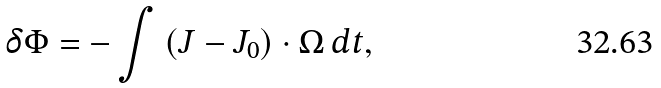<formula> <loc_0><loc_0><loc_500><loc_500>\delta \Phi = - \int { \left ( { { J } - { J } _ { 0 } } \right ) \cdot { \Omega } } \, d t ,</formula> 